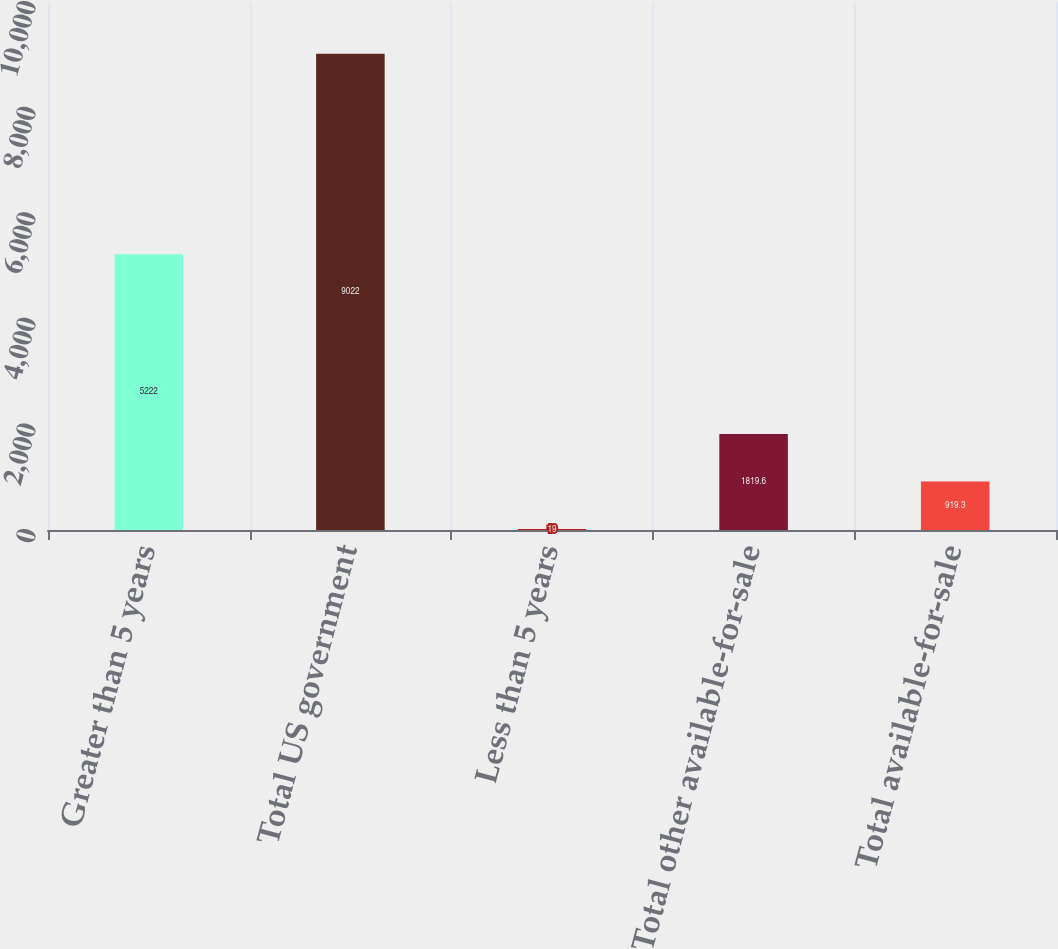Convert chart to OTSL. <chart><loc_0><loc_0><loc_500><loc_500><bar_chart><fcel>Greater than 5 years<fcel>Total US government<fcel>Less than 5 years<fcel>Total other available-for-sale<fcel>Total available-for-sale<nl><fcel>5222<fcel>9022<fcel>19<fcel>1819.6<fcel>919.3<nl></chart> 